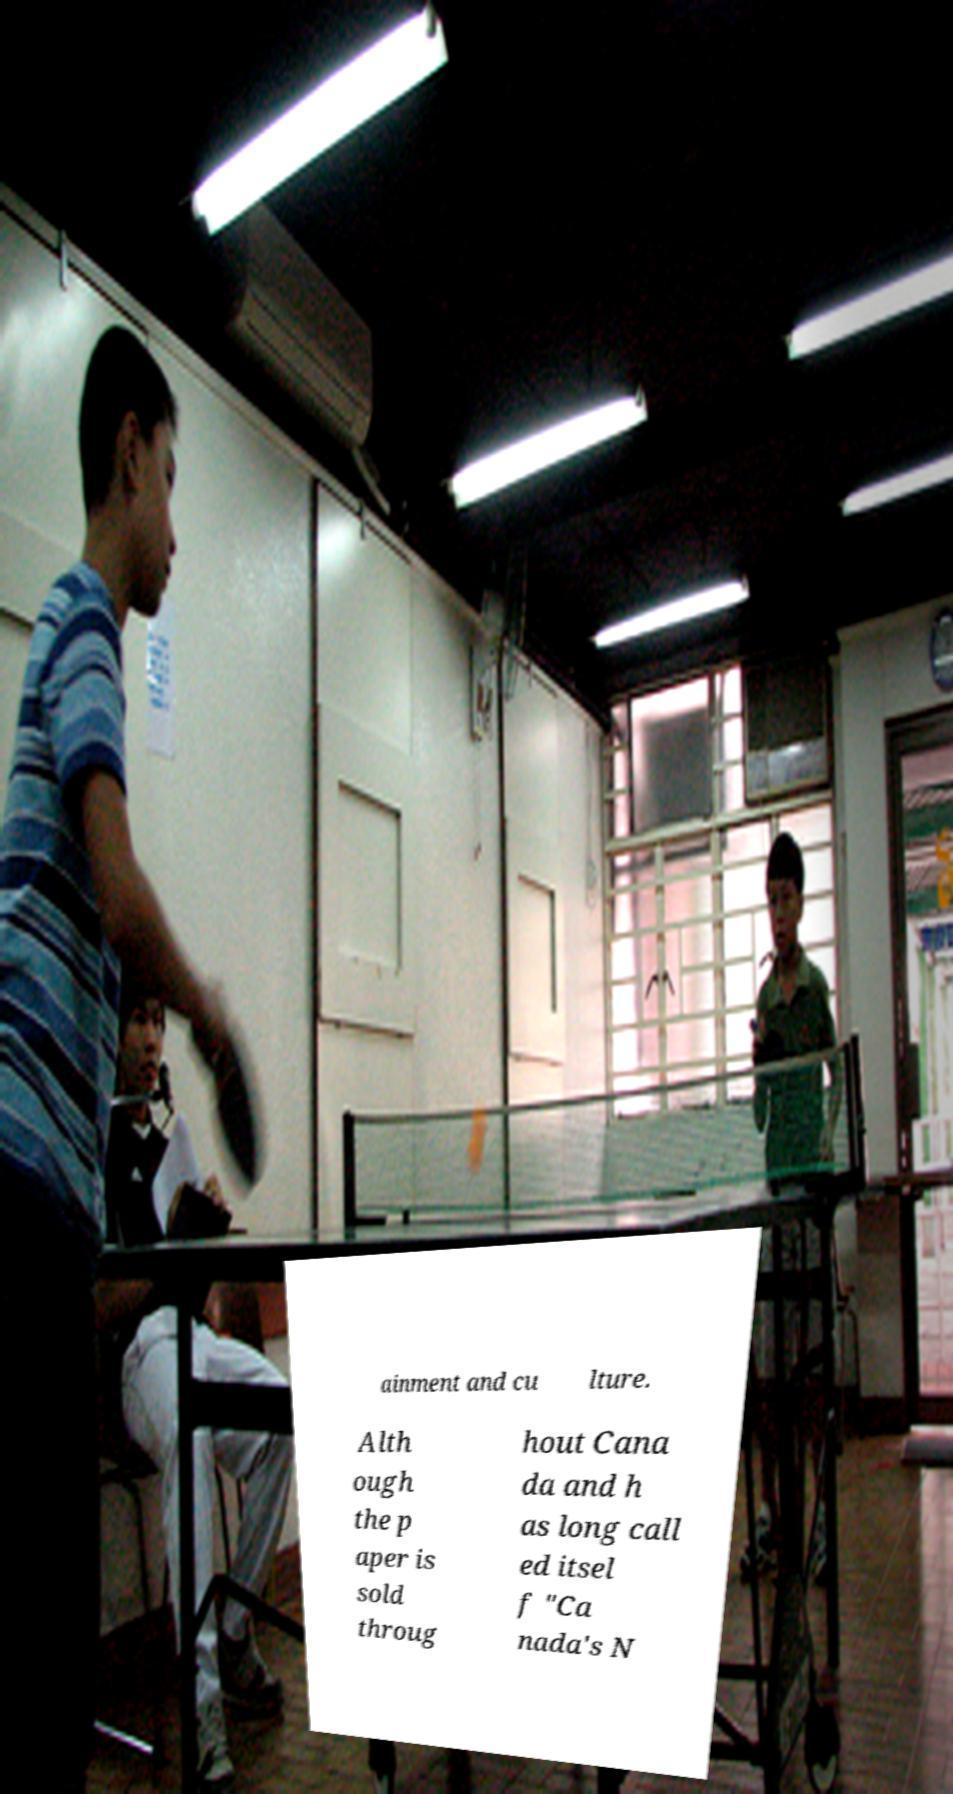Could you assist in decoding the text presented in this image and type it out clearly? ainment and cu lture. Alth ough the p aper is sold throug hout Cana da and h as long call ed itsel f "Ca nada's N 